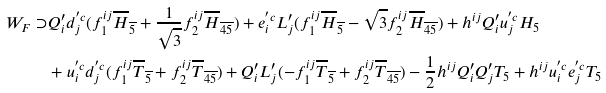Convert formula to latex. <formula><loc_0><loc_0><loc_500><loc_500>W _ { F } \supset & Q ^ { \prime } _ { i } d _ { j } ^ { ^ { \prime } c } ( f _ { 1 } ^ { i j } \overline { H } _ { \overline { 5 } } + \frac { 1 } { \sqrt { 3 } } f _ { 2 } ^ { i j } \overline { H } _ { \overline { 4 5 } } ) + e _ { i } ^ { ^ { \prime } c } L ^ { \prime } _ { j } ( f _ { 1 } ^ { i j } \overline { H } _ { \overline { 5 } } - \sqrt { 3 } f _ { 2 } ^ { i j } \overline { H } _ { \overline { 4 5 } } ) + h ^ { i j } Q ^ { \prime } _ { i } u _ { j } ^ { ^ { \prime } c } H _ { 5 } \\ & + u _ { i } ^ { ^ { \prime } c } d _ { j } ^ { ^ { \prime } c } ( f _ { 1 } ^ { i j } \overline { T } _ { \overline { 5 } } + f _ { 2 } ^ { i j } \overline { T } _ { \overline { 4 5 } } ) + Q ^ { \prime } _ { i } L ^ { \prime } _ { j } ( - f _ { 1 } ^ { i j } \overline { T } _ { \overline { 5 } } + f _ { 2 } ^ { i j } \overline { T } _ { \overline { 4 5 } } ) - \frac { 1 } { 2 } h ^ { i j } Q ^ { \prime } _ { i } Q ^ { \prime } _ { j } T _ { 5 } + h ^ { i j } u _ { i } ^ { ^ { \prime } c } e _ { j } ^ { ^ { \prime } c } T _ { 5 }</formula> 